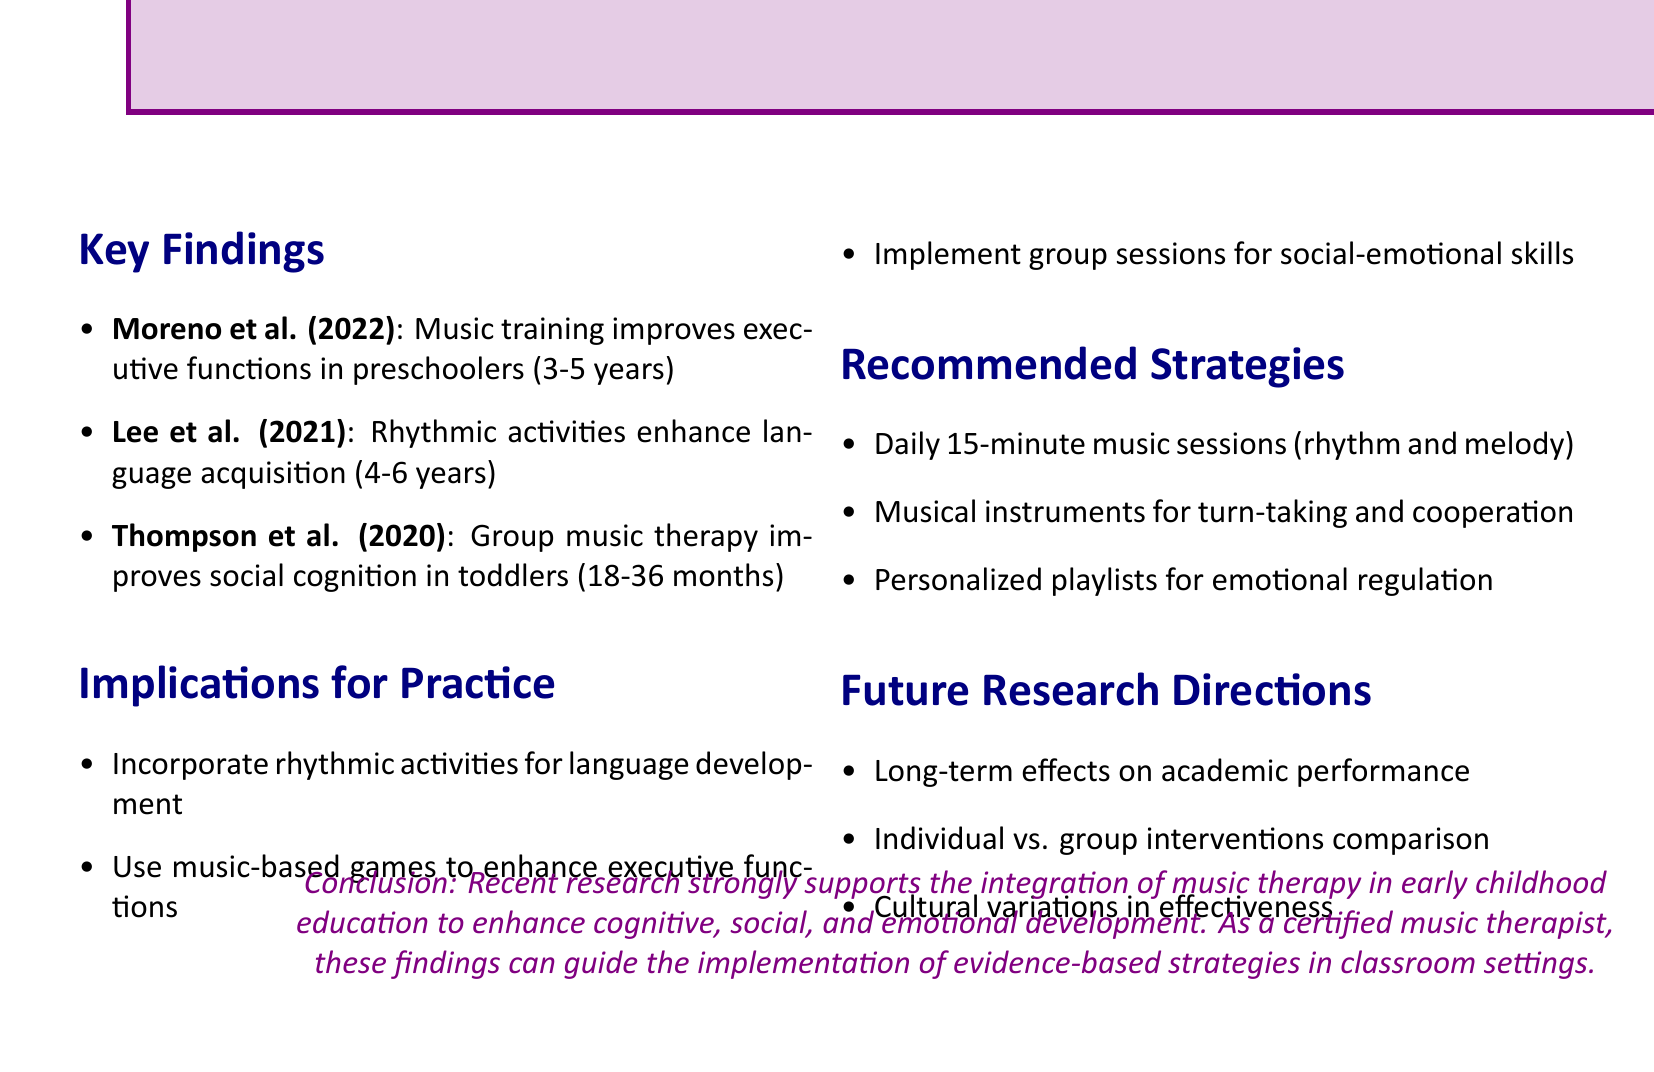What study shows the effect of music training on executive functions? The document mentions Moreno et al. (2022) as the study demonstrating the improvement of executive functions due to music training.
Answer: Moreno et al. (2022) What age group does Lee et al. (2021) focus on? The document specifies that Lee et al. (2021) focuses on children aged 4-6 years.
Answer: 4-6 years What type of activities enhance language acquisition according to Lee et al. (2021)? The finding by Lee et al. (2021) highlights that rhythmic activities enhance language acquisition.
Answer: Rhythmic activities Which strategy is recommended for emotional regulation during transitions? The document suggests creating personalized playlists to support emotional regulation during transitions.
Answer: Personalized playlists What is one implication for practice listed in the document? The document indicates that incorporating rhythmic activities to support language development is an implication for practice.
Answer: Incorporate rhythmic activities What is a future research direction mentioned related to academic performance? The document states that future research directions include studying the long-term effects of early childhood music therapy on academic performance.
Answer: Long-term effects on academic performance What journal published the study by Thompson et al. (2020)? The document indicates that Thompson et al. (2020) was published in Developmental Science.
Answer: Developmental Science How long should daily music sessions last according to the recommended strategies? The document recommends that daily music sessions should last for 15 minutes.
Answer: 15 minutes 